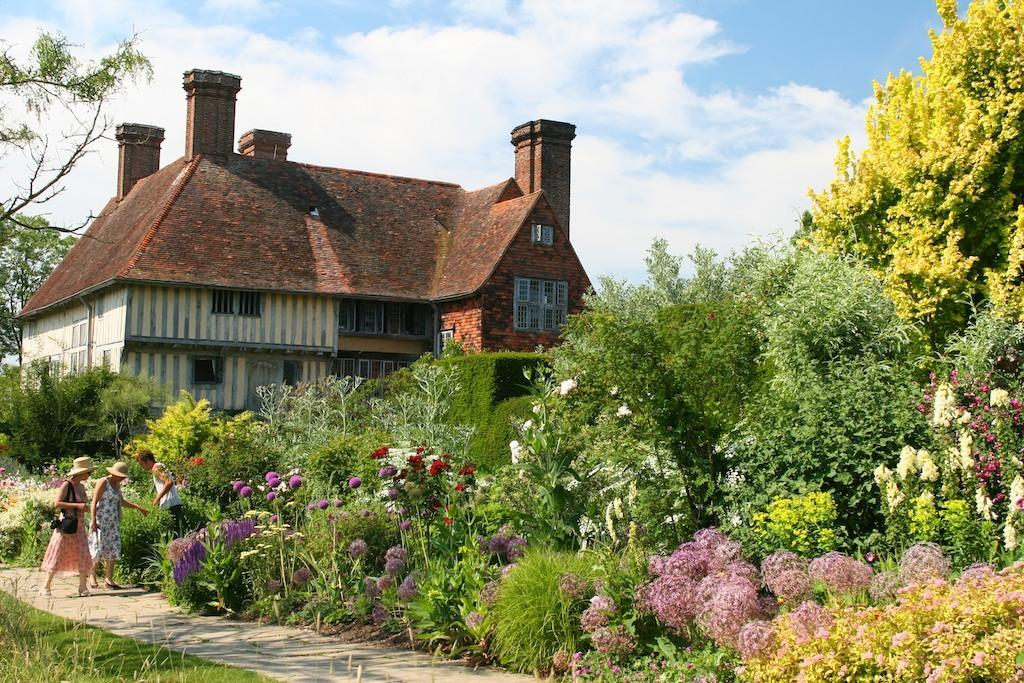What type of structure is present in the image? There is a house in the image. What can be seen surrounding the house? There are trees around the house. What other types of vegetation are visible in the image? There are plants, flowers, and grass in the image. What is visible in the background of the image? The sky is visible in the background of the image. What type of jam is being produced by the house in the image? There is no jam production or reference to jam in the image. 